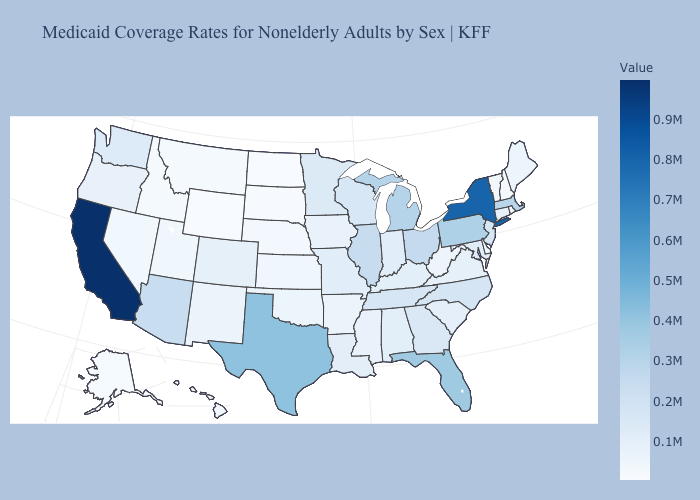Among the states that border Indiana , does Illinois have the highest value?
Keep it brief. No. Which states have the lowest value in the USA?
Keep it brief. Wyoming. Does California have the highest value in the USA?
Give a very brief answer. Yes. Is the legend a continuous bar?
Give a very brief answer. Yes. Does Wyoming have the lowest value in the USA?
Concise answer only. Yes. Does Illinois have the lowest value in the MidWest?
Give a very brief answer. No. 